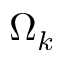<formula> <loc_0><loc_0><loc_500><loc_500>\Omega _ { k }</formula> 